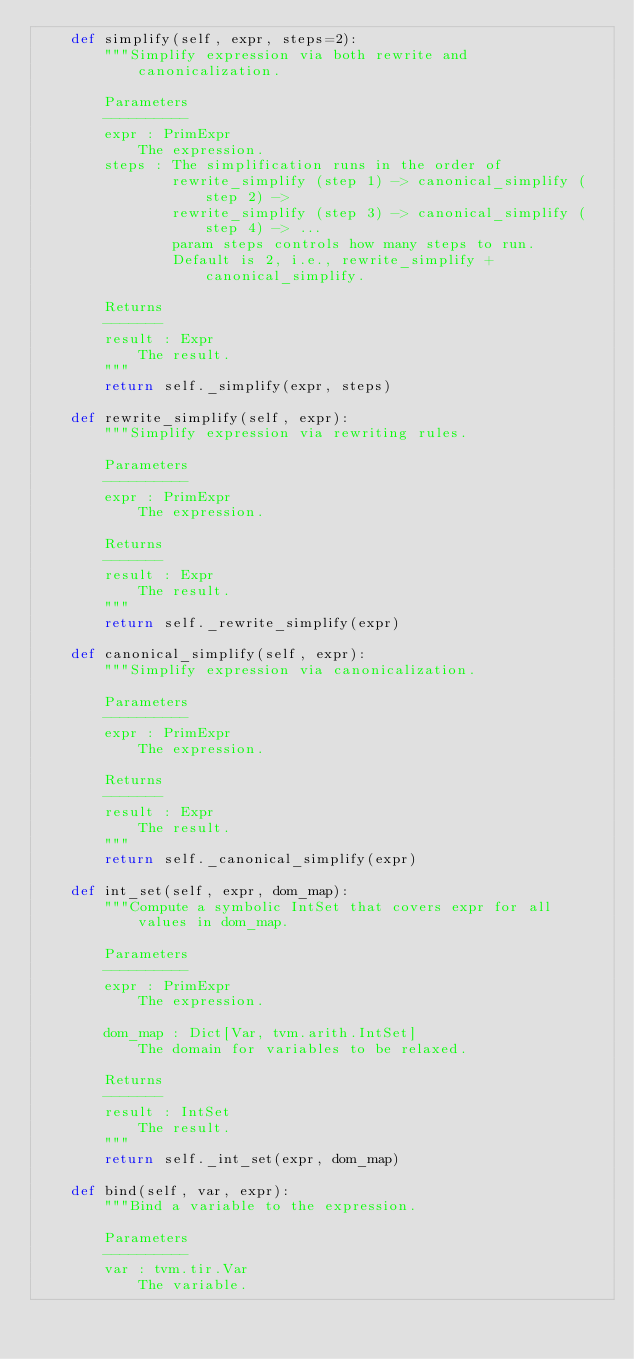<code> <loc_0><loc_0><loc_500><loc_500><_Python_>    def simplify(self, expr, steps=2):
        """Simplify expression via both rewrite and canonicalization.

        Parameters
        ----------
        expr : PrimExpr
            The expression.
        steps : The simplification runs in the order of
                rewrite_simplify (step 1) -> canonical_simplify (step 2) ->
                rewrite_simplify (step 3) -> canonical_simplify (step 4) -> ...
                param steps controls how many steps to run.
                Default is 2, i.e., rewrite_simplify + canonical_simplify.

        Returns
        -------
        result : Expr
            The result.
        """
        return self._simplify(expr, steps)

    def rewrite_simplify(self, expr):
        """Simplify expression via rewriting rules.

        Parameters
        ----------
        expr : PrimExpr
            The expression.

        Returns
        -------
        result : Expr
            The result.
        """
        return self._rewrite_simplify(expr)

    def canonical_simplify(self, expr):
        """Simplify expression via canonicalization.

        Parameters
        ----------
        expr : PrimExpr
            The expression.

        Returns
        -------
        result : Expr
            The result.
        """
        return self._canonical_simplify(expr)

    def int_set(self, expr, dom_map):
        """Compute a symbolic IntSet that covers expr for all values in dom_map.

        Parameters
        ----------
        expr : PrimExpr
            The expression.

        dom_map : Dict[Var, tvm.arith.IntSet]
            The domain for variables to be relaxed.

        Returns
        -------
        result : IntSet
            The result.
        """
        return self._int_set(expr, dom_map)

    def bind(self, var, expr):
        """Bind a variable to the expression.

        Parameters
        ----------
        var : tvm.tir.Var
            The variable.
</code> 